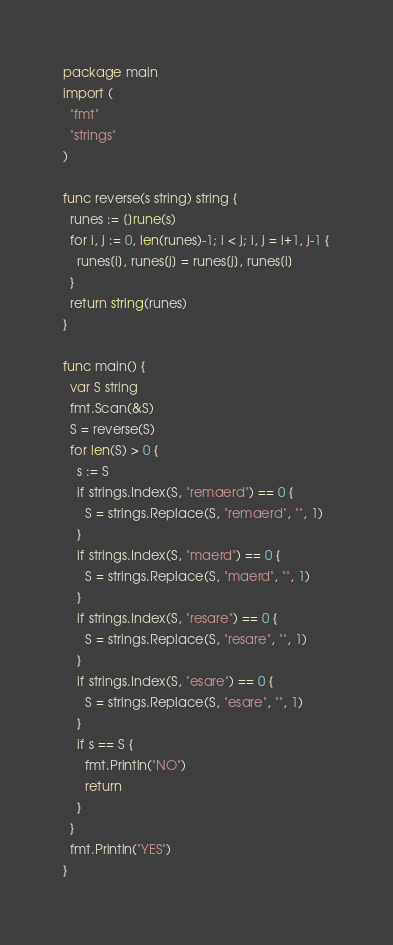Convert code to text. <code><loc_0><loc_0><loc_500><loc_500><_Go_>package main
import (
  "fmt"
  "strings"
)

func reverse(s string) string {
  runes := []rune(s)
  for i, j := 0, len(runes)-1; i < j; i, j = i+1, j-1 {
    runes[i], runes[j] = runes[j], runes[i]
  }
  return string(runes)
}

func main() {
  var S string
  fmt.Scan(&S)
  S = reverse(S)
  for len(S) > 0 {
    s := S
    if strings.Index(S, "remaerd") == 0 {
      S = strings.Replace(S, "remaerd", "", 1)
    }
    if strings.Index(S, "maerd") == 0 {
      S = strings.Replace(S, "maerd", "", 1)
    }
    if strings.Index(S, "resare") == 0 {
      S = strings.Replace(S, "resare", "", 1)
    }
    if strings.Index(S, "esare") == 0 {
      S = strings.Replace(S, "esare", "", 1)
    }
    if s == S {
      fmt.Println("NO")
      return
    }
  }
  fmt.Println("YES")
}
</code> 